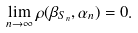Convert formula to latex. <formula><loc_0><loc_0><loc_500><loc_500>\lim _ { n \to \infty } \rho ( \beta _ { S _ { n } } , \alpha _ { n } ) = 0 .</formula> 